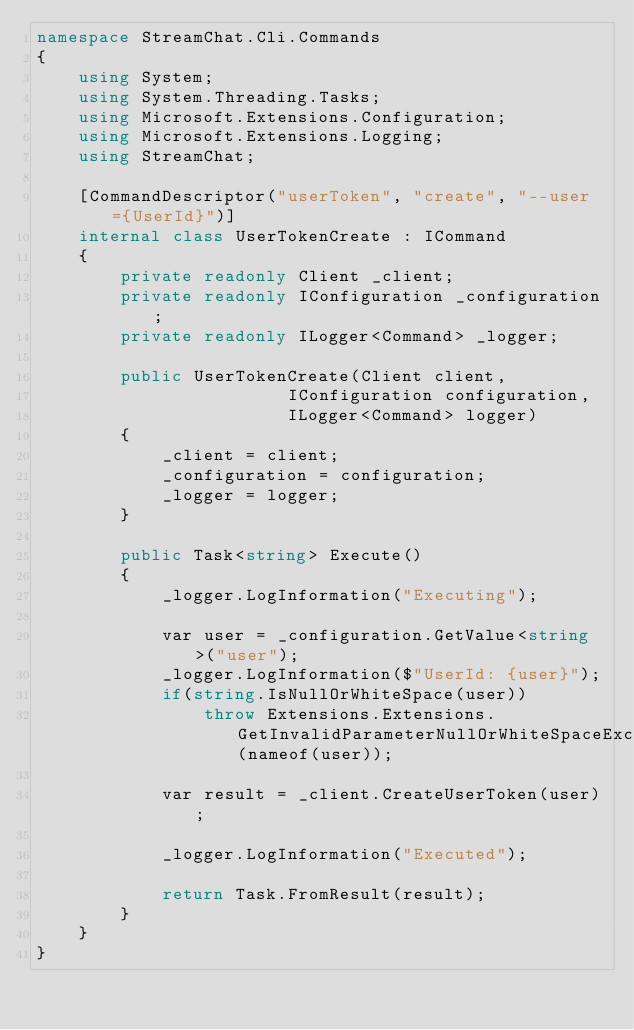Convert code to text. <code><loc_0><loc_0><loc_500><loc_500><_C#_>namespace StreamChat.Cli.Commands
{
    using System;
    using System.Threading.Tasks;
	using Microsoft.Extensions.Configuration;
	using Microsoft.Extensions.Logging;
	using StreamChat;

	[CommandDescriptor("userToken", "create", "--user={UserId}")]
	internal class UserTokenCreate : ICommand
	{
		private readonly Client _client;
		private readonly IConfiguration _configuration;
		private readonly ILogger<Command> _logger;

		public UserTokenCreate(Client client, 
						IConfiguration configuration,
						ILogger<Command> logger)
		{
			_client = client;
			_configuration = configuration;
			_logger = logger;
		}

		public Task<string> Execute()
		{
			_logger.LogInformation("Executing");

			var user = _configuration.GetValue<string>("user");
			_logger.LogInformation($"UserId: {user}");
			if(string.IsNullOrWhiteSpace(user))
				throw Extensions.Extensions.GetInvalidParameterNullOrWhiteSpaceException(nameof(user));

			var result = _client.CreateUserToken(user);

			_logger.LogInformation("Executed");

			return Task.FromResult(result);
		}
	}
}
</code> 